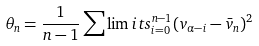<formula> <loc_0><loc_0><loc_500><loc_500>\theta _ { n } = \frac { 1 } { n - 1 } \sum \lim i t s _ { i = 0 } ^ { n - 1 } ( v _ { \alpha - i } - \bar { v } _ { n } ) ^ { 2 }</formula> 